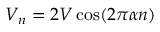Convert formula to latex. <formula><loc_0><loc_0><loc_500><loc_500>V _ { n } = 2 V \cos ( 2 \pi \alpha n )</formula> 